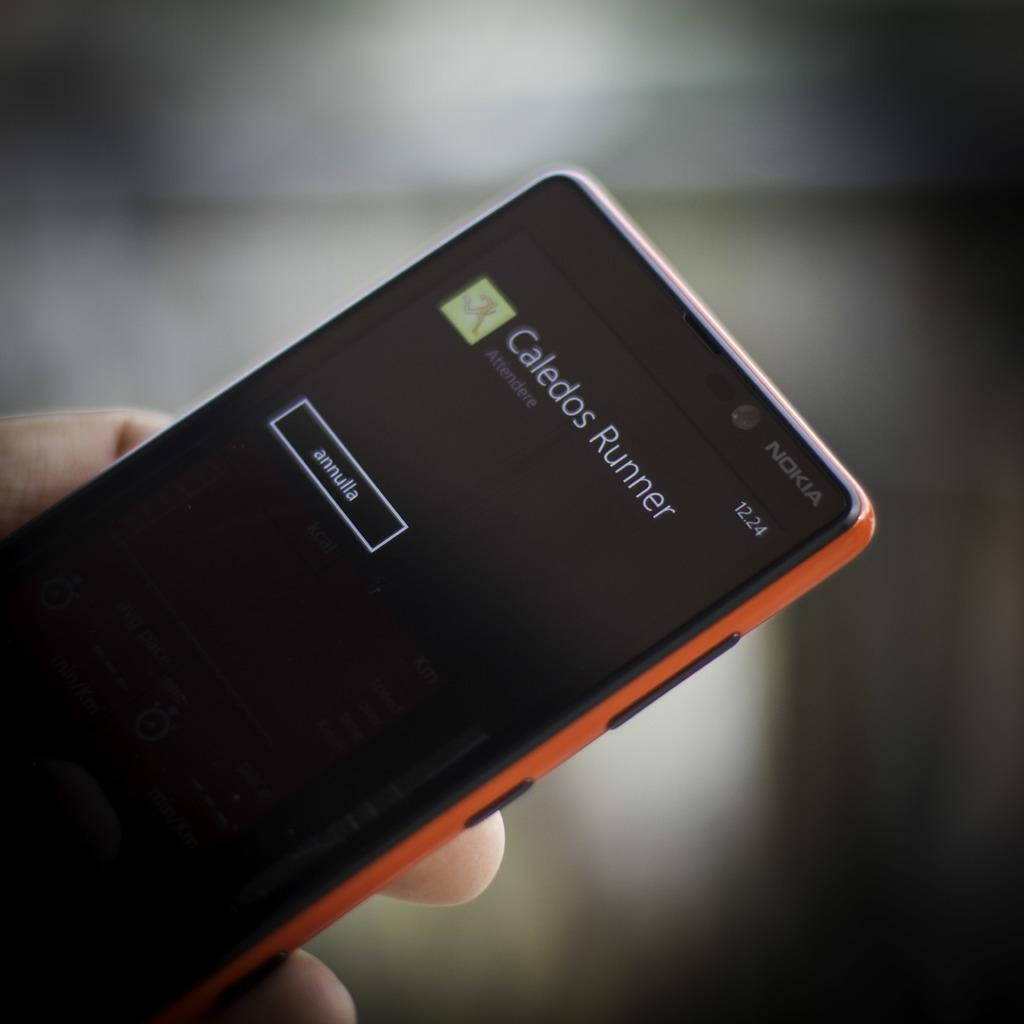Provide a one-sentence caption for the provided image. a phone that has Caledos Runner on it. 